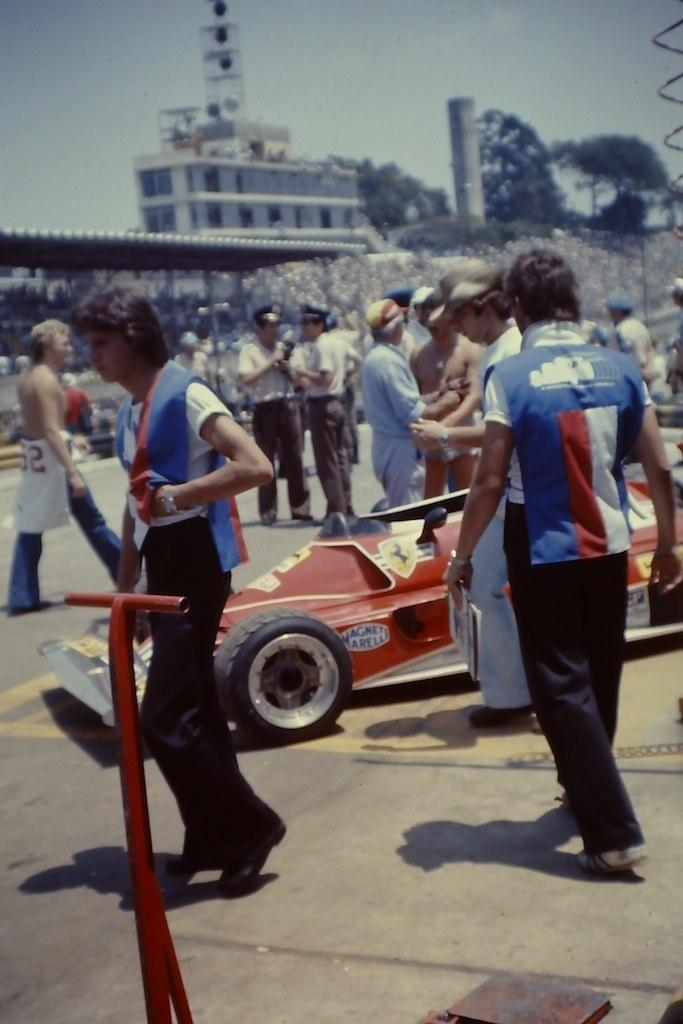What type of vehicle is in the picture? There is a sports car in the picture. What else can be seen in the picture besides the sports car? There is a group of people standing and a building in the picture. Are there any natural elements in the picture? Yes, there are trees in the picture. What can be seen in the background of the picture? The sky is visible in the background of the picture. How many grapes are on the sports car in the picture? There are no grapes present on the sports car in the picture. What unit of measurement is used to determine the height of the building in the picture? The provided facts do not mention any specific unit of measurement for the building's height. 